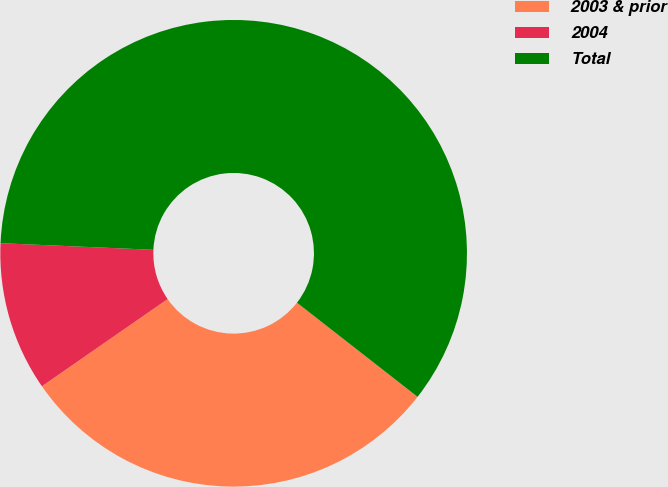Convert chart to OTSL. <chart><loc_0><loc_0><loc_500><loc_500><pie_chart><fcel>2003 & prior<fcel>2004<fcel>Total<nl><fcel>29.8%<fcel>10.34%<fcel>59.86%<nl></chart> 